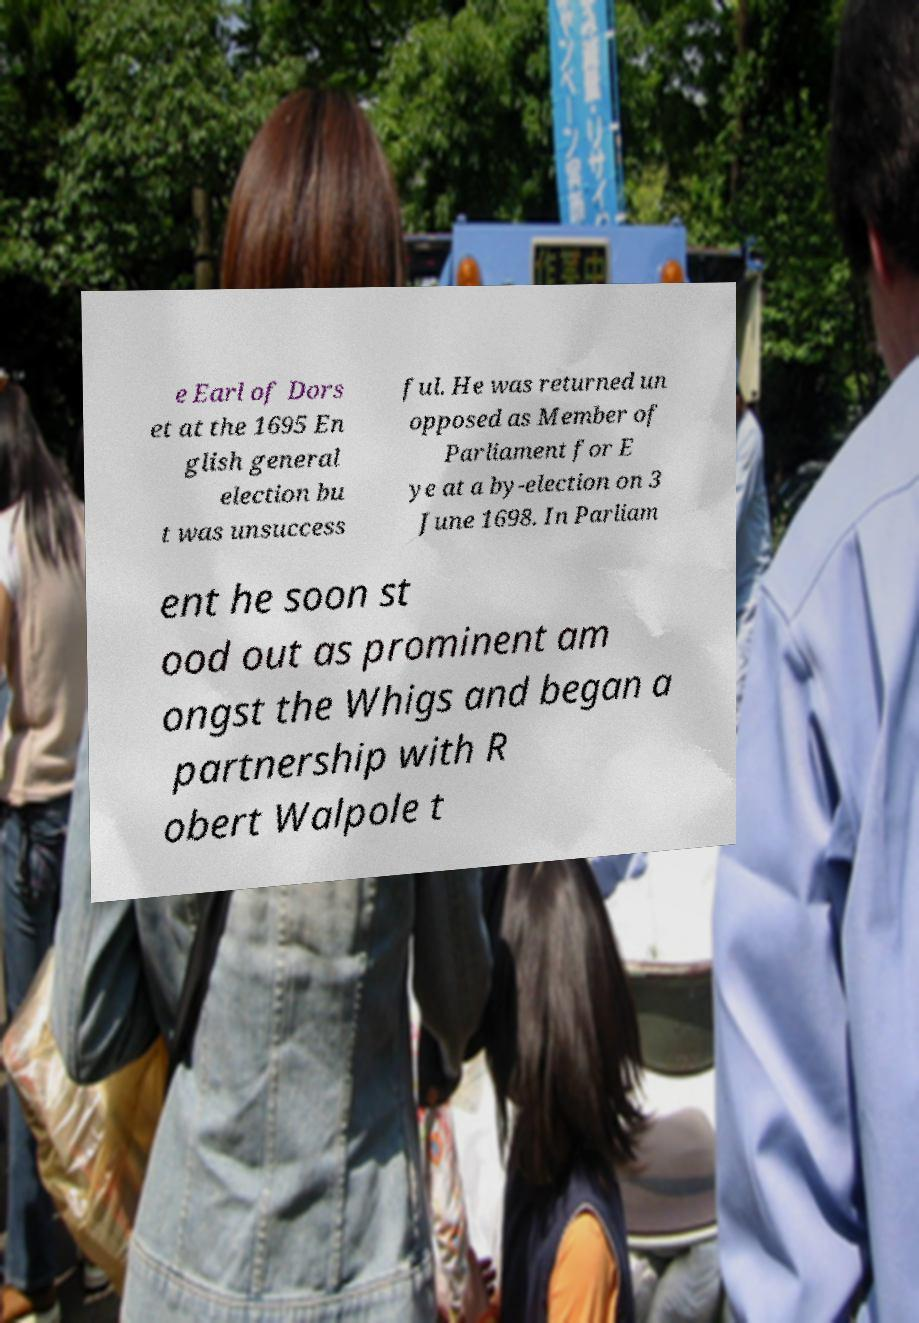There's text embedded in this image that I need extracted. Can you transcribe it verbatim? e Earl of Dors et at the 1695 En glish general election bu t was unsuccess ful. He was returned un opposed as Member of Parliament for E ye at a by-election on 3 June 1698. In Parliam ent he soon st ood out as prominent am ongst the Whigs and began a partnership with R obert Walpole t 